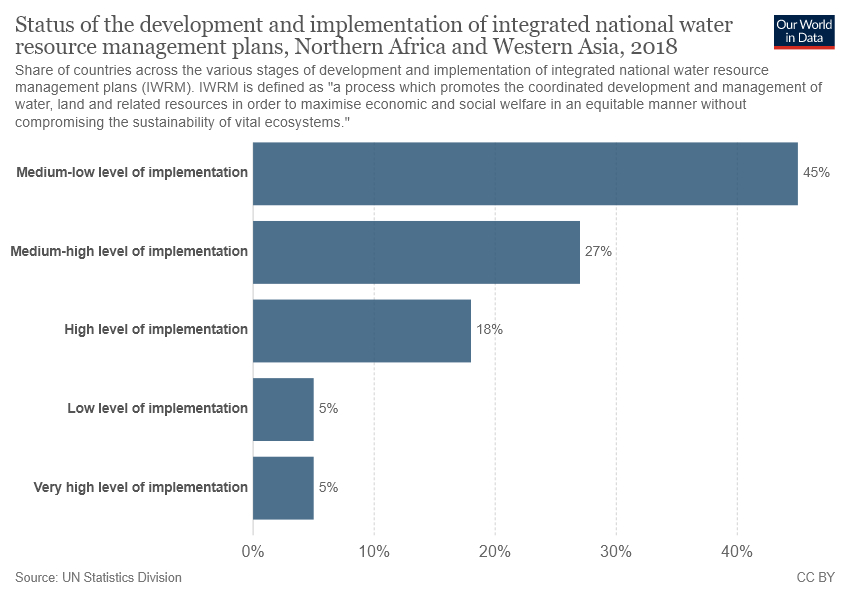Point out several critical features in this image. There is only one color shown in the graph. 